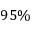<formula> <loc_0><loc_0><loc_500><loc_500>9 5 \%</formula> 